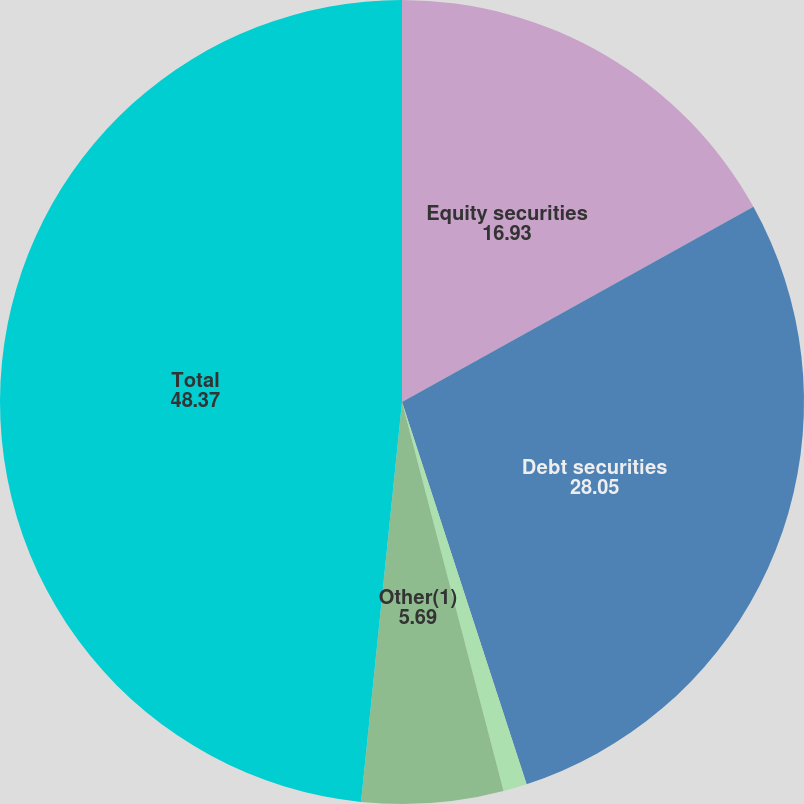<chart> <loc_0><loc_0><loc_500><loc_500><pie_chart><fcel>Equity securities<fcel>Debt securities<fcel>Real estate<fcel>Other(1)<fcel>Total<nl><fcel>16.93%<fcel>28.05%<fcel>0.95%<fcel>5.69%<fcel>48.37%<nl></chart> 